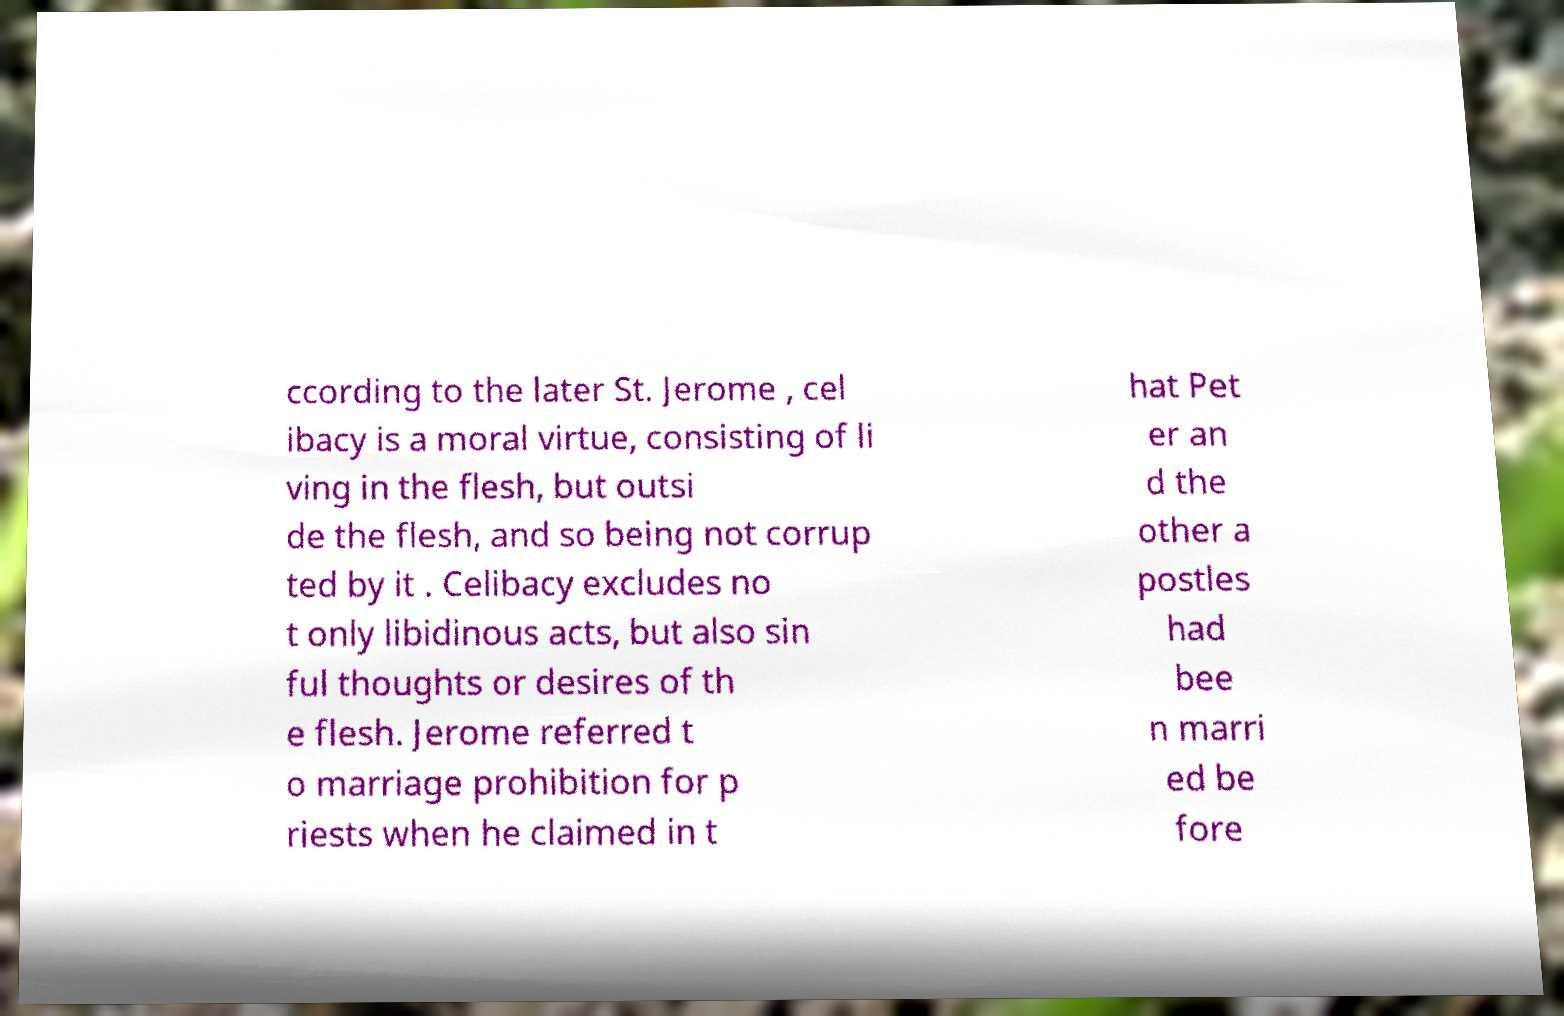What messages or text are displayed in this image? I need them in a readable, typed format. ccording to the later St. Jerome , cel ibacy is a moral virtue, consisting of li ving in the flesh, but outsi de the flesh, and so being not corrup ted by it . Celibacy excludes no t only libidinous acts, but also sin ful thoughts or desires of th e flesh. Jerome referred t o marriage prohibition for p riests when he claimed in t hat Pet er an d the other a postles had bee n marri ed be fore 